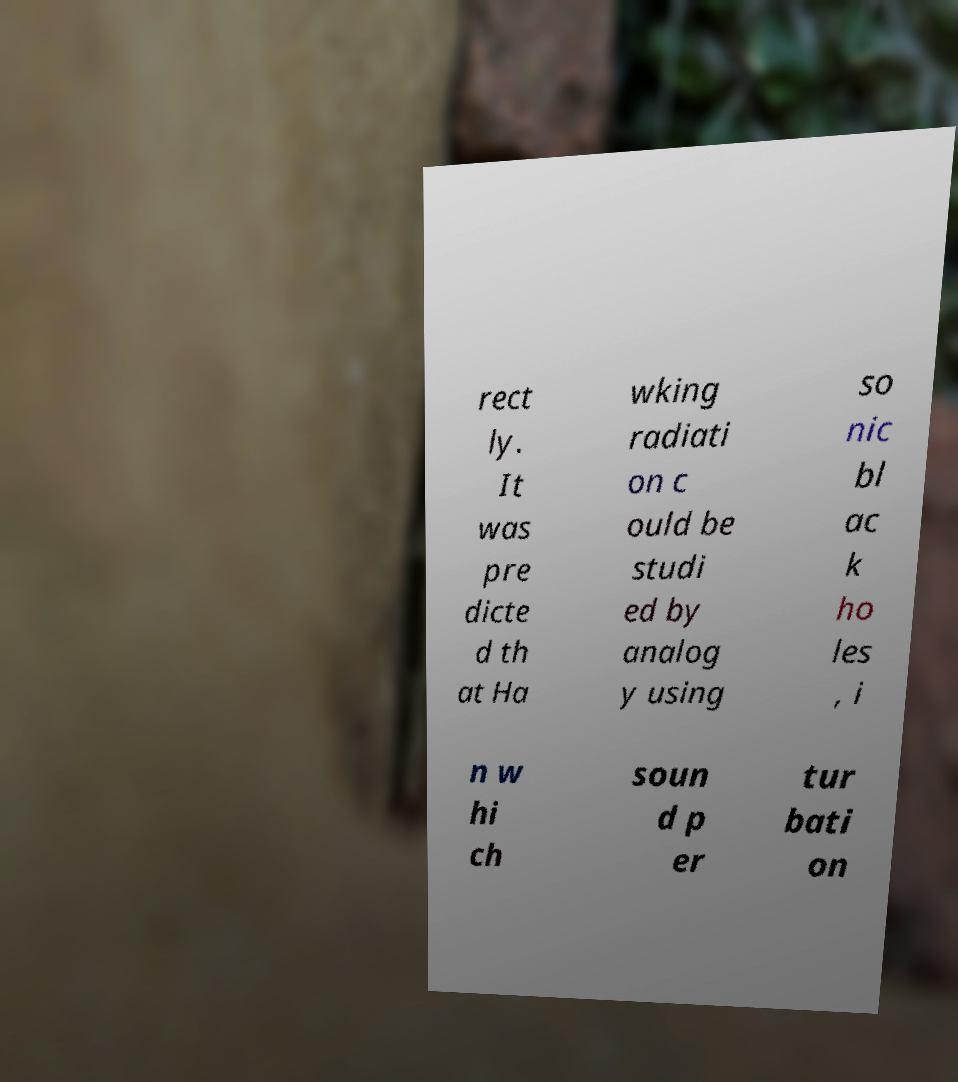Please read and relay the text visible in this image. What does it say? rect ly. It was pre dicte d th at Ha wking radiati on c ould be studi ed by analog y using so nic bl ac k ho les , i n w hi ch soun d p er tur bati on 